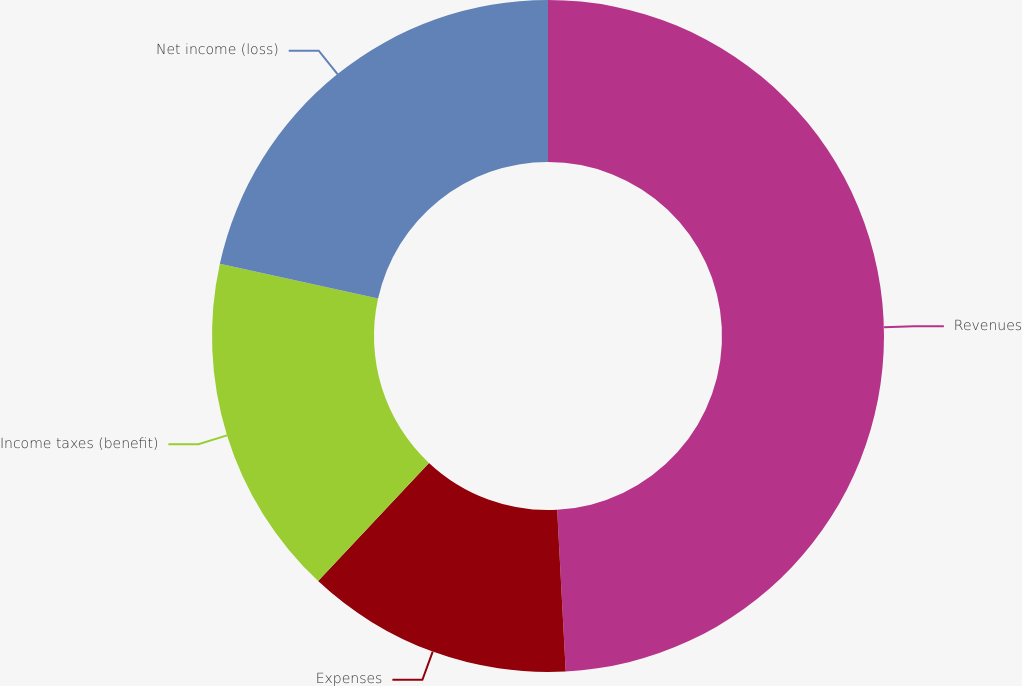Convert chart. <chart><loc_0><loc_0><loc_500><loc_500><pie_chart><fcel>Revenues<fcel>Expenses<fcel>Income taxes (benefit)<fcel>Net income (loss)<nl><fcel>49.16%<fcel>12.83%<fcel>16.46%<fcel>21.55%<nl></chart> 